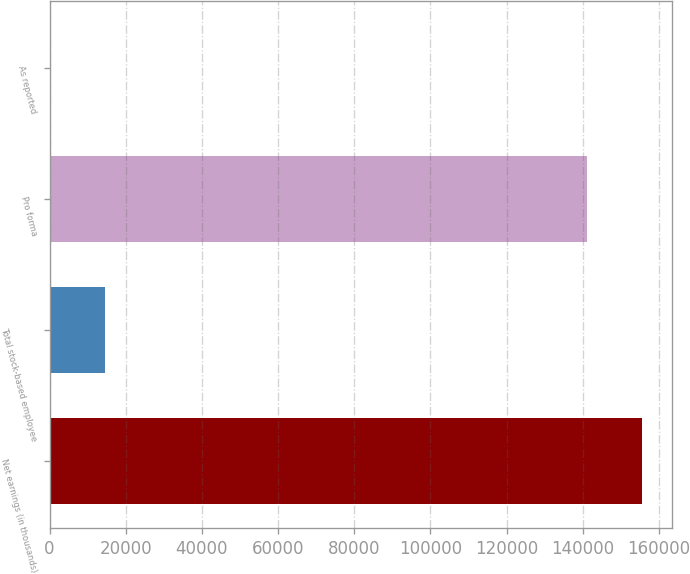Convert chart. <chart><loc_0><loc_0><loc_500><loc_500><bar_chart><fcel>Net earnings (in thousands)<fcel>Total stock-based employee<fcel>Pro forma<fcel>As reported<nl><fcel>155635<fcel>14627.2<fcel>141010<fcel>1.81<nl></chart> 